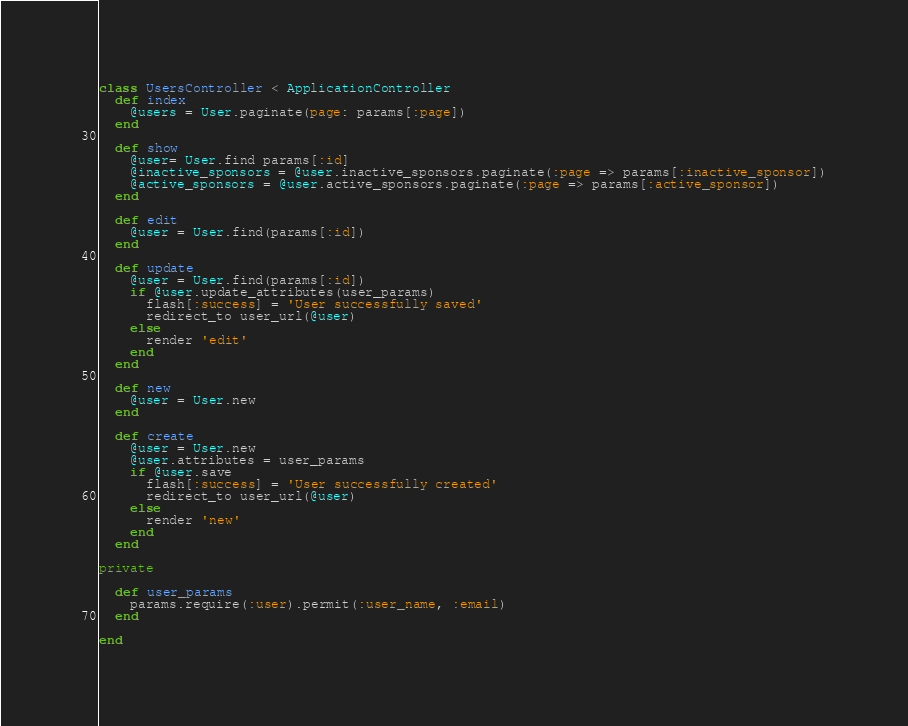<code> <loc_0><loc_0><loc_500><loc_500><_Ruby_>class UsersController < ApplicationController
  def index
    @users = User.paginate(page: params[:page])
  end

  def show
    @user= User.find params[:id]
    @inactive_sponsors = @user.inactive_sponsors.paginate(:page => params[:inactive_sponsor])
    @active_sponsors = @user.active_sponsors.paginate(:page => params[:active_sponsor])
  end

  def edit
    @user = User.find(params[:id])
  end

  def update
    @user = User.find(params[:id])
    if @user.update_attributes(user_params)
      flash[:success] = 'User successfully saved'
      redirect_to user_url(@user)
    else
      render 'edit'
    end
  end

  def new
    @user = User.new
  end

  def create
    @user = User.new
    @user.attributes = user_params
    if @user.save
      flash[:success] = 'User successfully created'
      redirect_to user_url(@user)
    else
      render 'new'
    end
  end

private

  def user_params
    params.require(:user).permit(:user_name, :email)
  end

end
</code> 